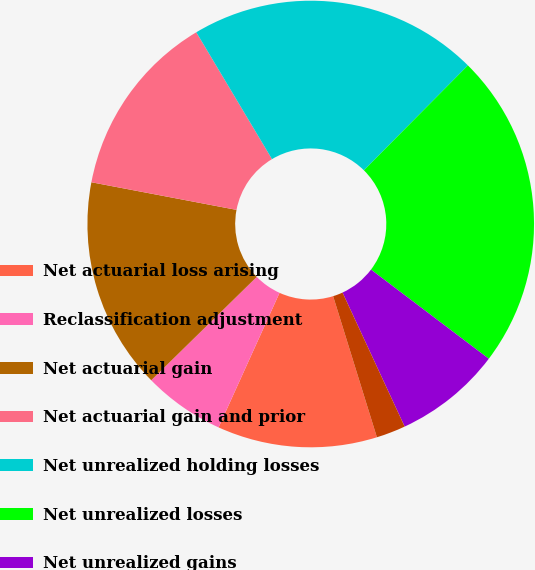Convert chart to OTSL. <chart><loc_0><loc_0><loc_500><loc_500><pie_chart><fcel>Net actuarial loss arising<fcel>Reclassification adjustment<fcel>Net actuarial gain<fcel>Net actuarial gain and prior<fcel>Net unrealized holding losses<fcel>Net unrealized losses<fcel>Net unrealized gains<fcel>Net unrealized losses arising<nl><fcel>11.56%<fcel>5.89%<fcel>15.33%<fcel>13.44%<fcel>20.99%<fcel>22.88%<fcel>7.78%<fcel>2.12%<nl></chart> 